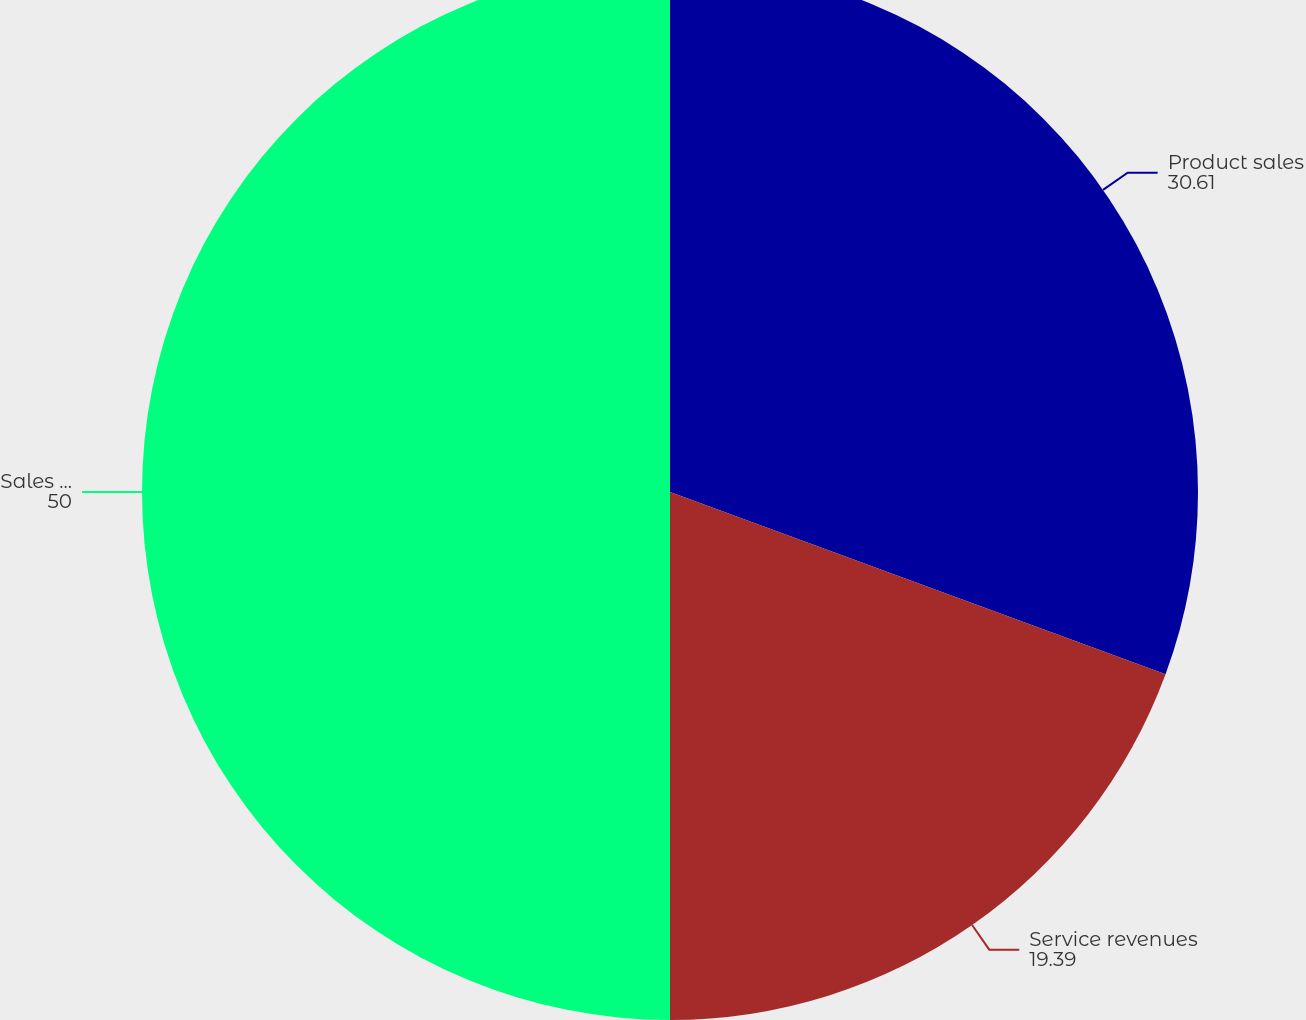Convert chart to OTSL. <chart><loc_0><loc_0><loc_500><loc_500><pie_chart><fcel>Product sales<fcel>Service revenues<fcel>Sales and service revenues<nl><fcel>30.61%<fcel>19.39%<fcel>50.0%<nl></chart> 